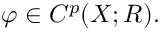<formula> <loc_0><loc_0><loc_500><loc_500>\varphi \in C ^ { p } ( X ; R ) .</formula> 